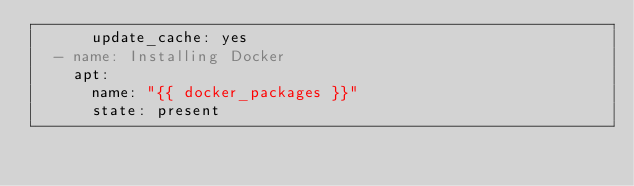<code> <loc_0><loc_0><loc_500><loc_500><_YAML_>      update_cache: yes
  - name: Installing Docker
    apt:
      name: "{{ docker_packages }}"
      state: present</code> 